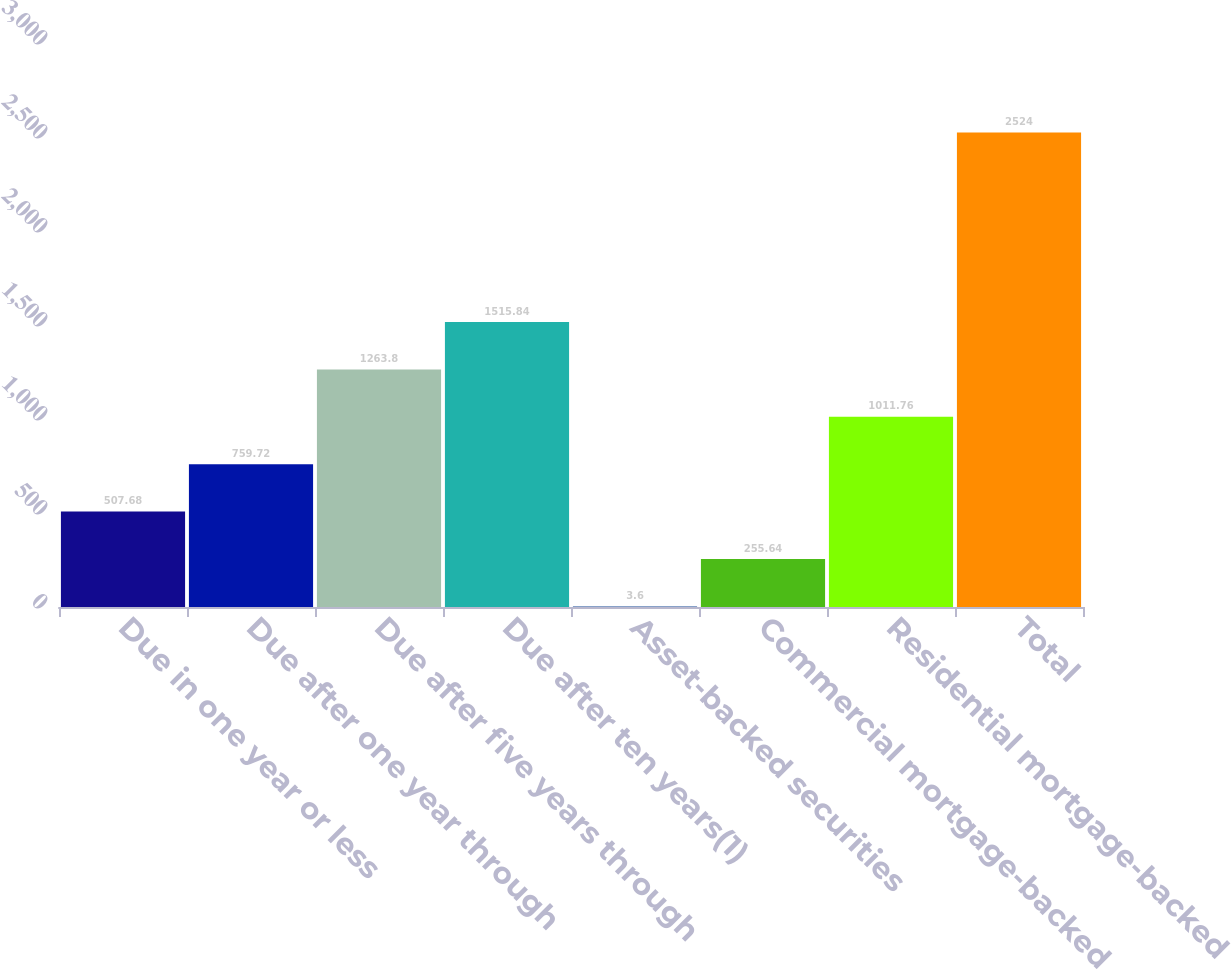<chart> <loc_0><loc_0><loc_500><loc_500><bar_chart><fcel>Due in one year or less<fcel>Due after one year through<fcel>Due after five years through<fcel>Due after ten years(1)<fcel>Asset-backed securities<fcel>Commercial mortgage-backed<fcel>Residential mortgage-backed<fcel>Total<nl><fcel>507.68<fcel>759.72<fcel>1263.8<fcel>1515.84<fcel>3.6<fcel>255.64<fcel>1011.76<fcel>2524<nl></chart> 